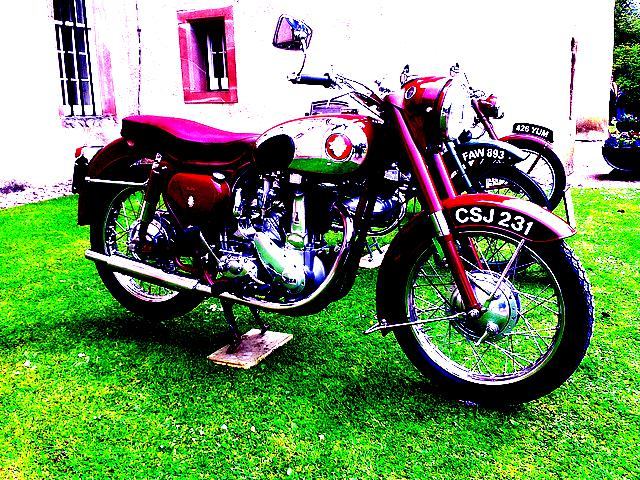How would the riding experience on this motorcycle differ from a modern bike? Riding this motorcycle would likely offer a rawer and more tactile experience compared to modern bikes, which are equipped with advanced technology for comfort, stability, and performance. This classic bike would appeal to those who appreciate a more traditional riding experience and the mechanical nature of vintage machines. 